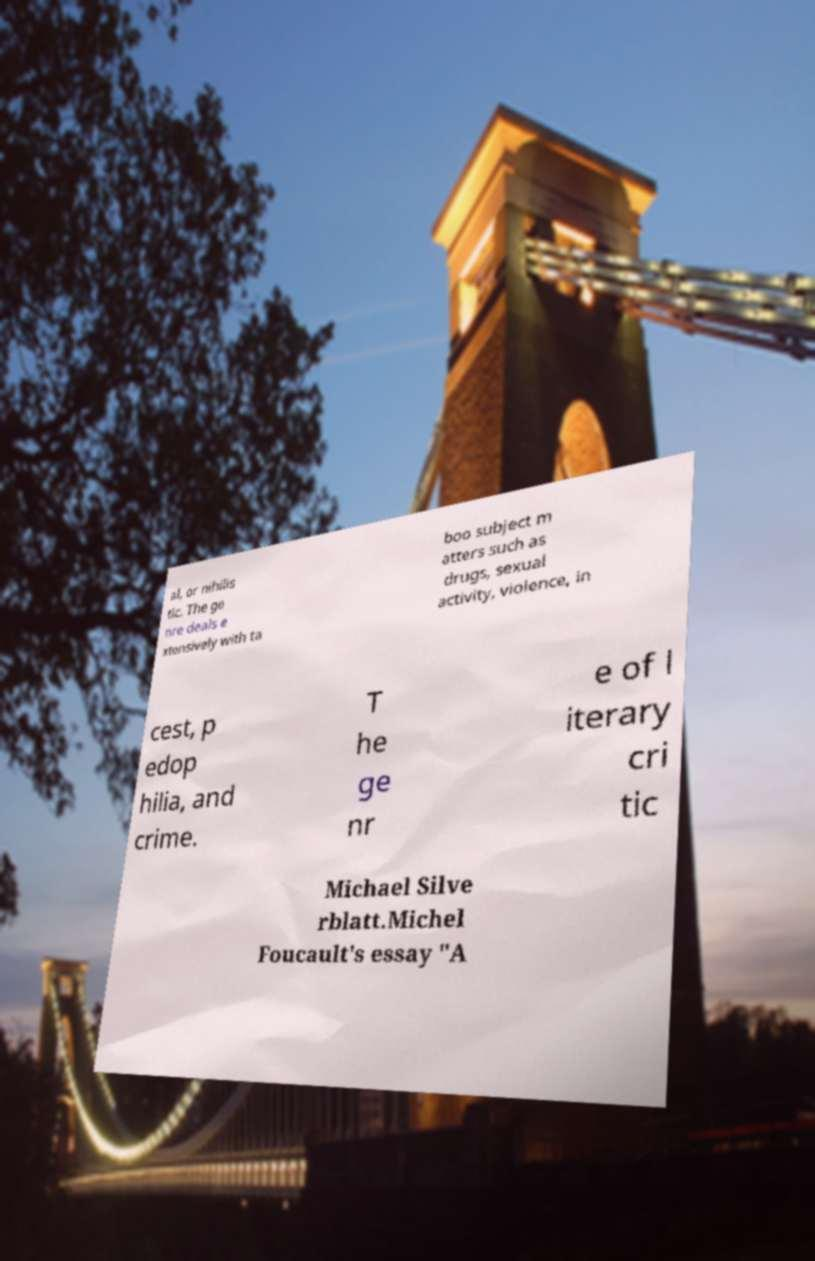Can you read and provide the text displayed in the image?This photo seems to have some interesting text. Can you extract and type it out for me? al, or nihilis tic. The ge nre deals e xtensively with ta boo subject m atters such as drugs, sexual activity, violence, in cest, p edop hilia, and crime. T he ge nr e of l iterary cri tic Michael Silve rblatt.Michel Foucault's essay "A 